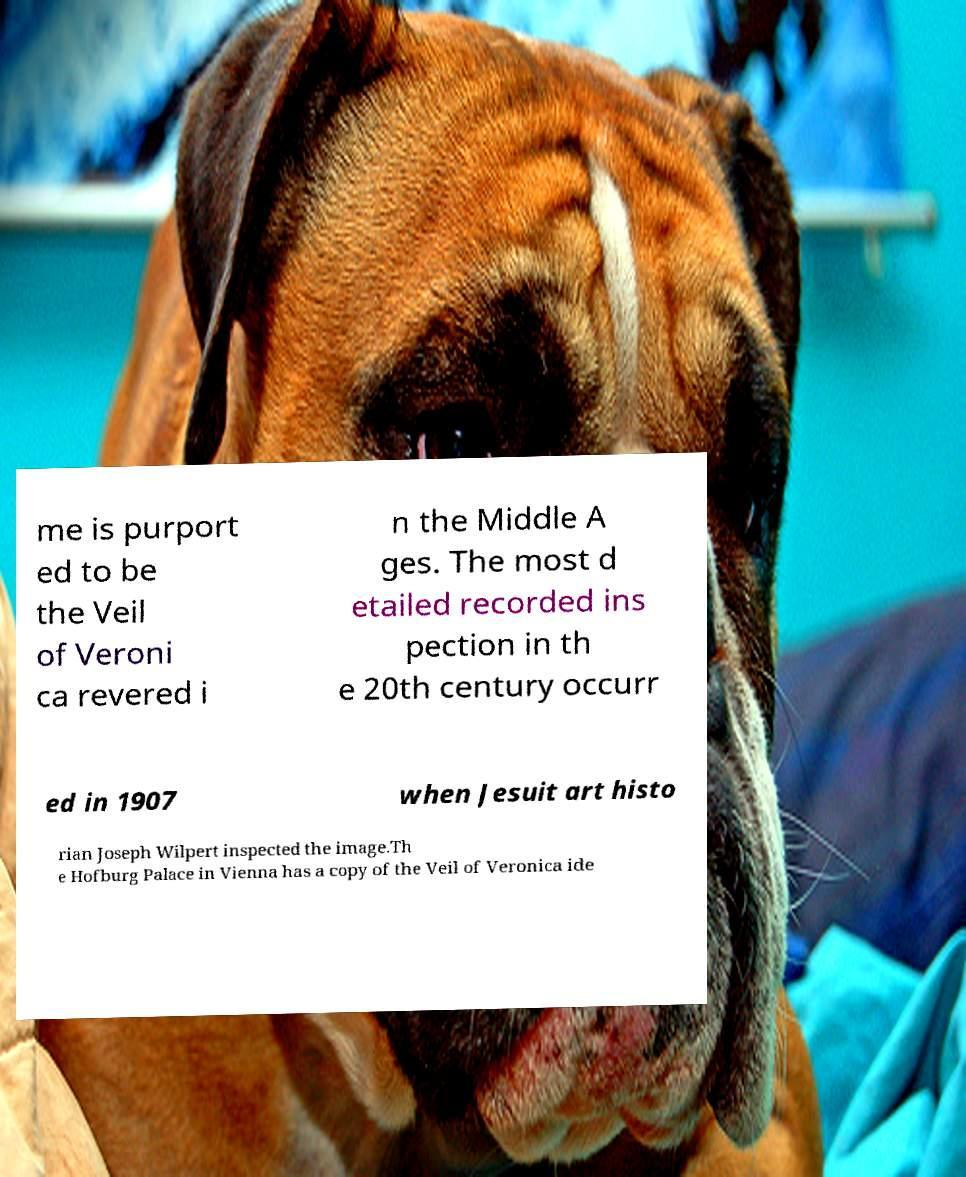Could you extract and type out the text from this image? me is purport ed to be the Veil of Veroni ca revered i n the Middle A ges. The most d etailed recorded ins pection in th e 20th century occurr ed in 1907 when Jesuit art histo rian Joseph Wilpert inspected the image.Th e Hofburg Palace in Vienna has a copy of the Veil of Veronica ide 